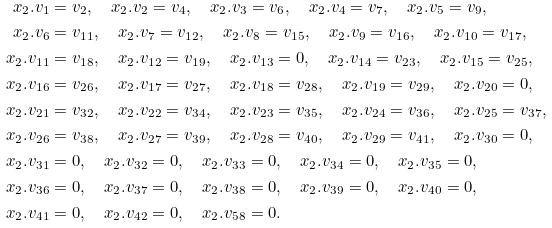<formula> <loc_0><loc_0><loc_500><loc_500>x _ { 2 } . v _ { 1 } & = v _ { 2 } , \quad x _ { 2 } . v _ { 2 } = v _ { 4 } , \quad x _ { 2 } . v _ { 3 } = v _ { 6 } , \quad x _ { 2 } . v _ { 4 } = v _ { 7 } , \quad x _ { 2 } . v _ { 5 } = v _ { 9 } , \\ x _ { 2 } . v _ { 6 } & = v _ { 1 1 } , \quad x _ { 2 } . v _ { 7 } = v _ { 1 2 } , \quad x _ { 2 } . v _ { 8 } = v _ { 1 5 } , \quad x _ { 2 } . v _ { 9 } = v _ { 1 6 } , \quad x _ { 2 } . v _ { 1 0 } = v _ { 1 7 } , \\ x _ { 2 } . v _ { 1 1 } & = v _ { 1 8 } , \quad x _ { 2 } . v _ { 1 2 } = v _ { 1 9 } , \quad x _ { 2 } . v _ { 1 3 } = 0 , \quad x _ { 2 } . v _ { 1 4 } = v _ { 2 3 } , \quad x _ { 2 } . v _ { 1 5 } = v _ { 2 5 } , \\ x _ { 2 } . v _ { 1 6 } & = v _ { 2 6 } , \quad x _ { 2 } . v _ { 1 7 } = v _ { 2 7 } , \quad x _ { 2 } . v _ { 1 8 } = v _ { 2 8 } , \quad x _ { 2 } . v _ { 1 9 } = v _ { 2 9 } , \quad x _ { 2 } . v _ { 2 0 } = 0 , \\ x _ { 2 } . v _ { 2 1 } & = v _ { 3 2 } , \quad x _ { 2 } . v _ { 2 2 } = v _ { 3 4 } , \quad x _ { 2 } . v _ { 2 3 } = v _ { 3 5 } , \quad x _ { 2 } . v _ { 2 4 } = v _ { 3 6 } , \quad x _ { 2 } . v _ { 2 5 } = v _ { 3 7 } , \\ x _ { 2 } . v _ { 2 6 } & = v _ { 3 8 } , \quad x _ { 2 } . v _ { 2 7 } = v _ { 3 9 } , \quad x _ { 2 } . v _ { 2 8 } = v _ { 4 0 } , \quad x _ { 2 } . v _ { 2 9 } = v _ { 4 1 } , \quad x _ { 2 } . v _ { 3 0 } = 0 , \\ x _ { 2 } . v _ { 3 1 } & = 0 , \quad x _ { 2 } . v _ { 3 2 } = 0 , \quad x _ { 2 } . v _ { 3 3 } = 0 , \quad x _ { 2 } . v _ { 3 4 } = 0 , \quad x _ { 2 } . v _ { 3 5 } = 0 , \\ x _ { 2 } . v _ { 3 6 } & = 0 , \quad x _ { 2 } . v _ { 3 7 } = 0 , \quad x _ { 2 } . v _ { 3 8 } = 0 , \quad x _ { 2 } . v _ { 3 9 } = 0 , \quad x _ { 2 } . v _ { 4 0 } = 0 , \\ x _ { 2 } . v _ { 4 1 } & = 0 , \quad x _ { 2 } . v _ { 4 2 } = 0 , \quad x _ { 2 } . v _ { 5 8 } = 0 .</formula> 